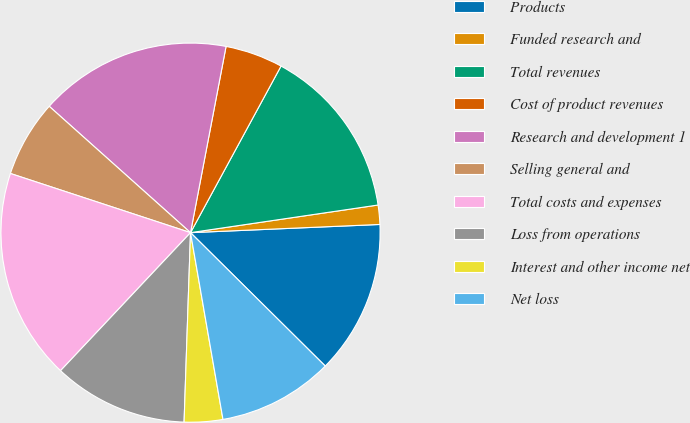Convert chart. <chart><loc_0><loc_0><loc_500><loc_500><pie_chart><fcel>Products<fcel>Funded research and<fcel>Total revenues<fcel>Cost of product revenues<fcel>Research and development 1<fcel>Selling general and<fcel>Total costs and expenses<fcel>Loss from operations<fcel>Interest and other income net<fcel>Net loss<nl><fcel>13.11%<fcel>1.64%<fcel>14.75%<fcel>4.92%<fcel>16.39%<fcel>6.56%<fcel>18.03%<fcel>11.48%<fcel>3.28%<fcel>9.84%<nl></chart> 